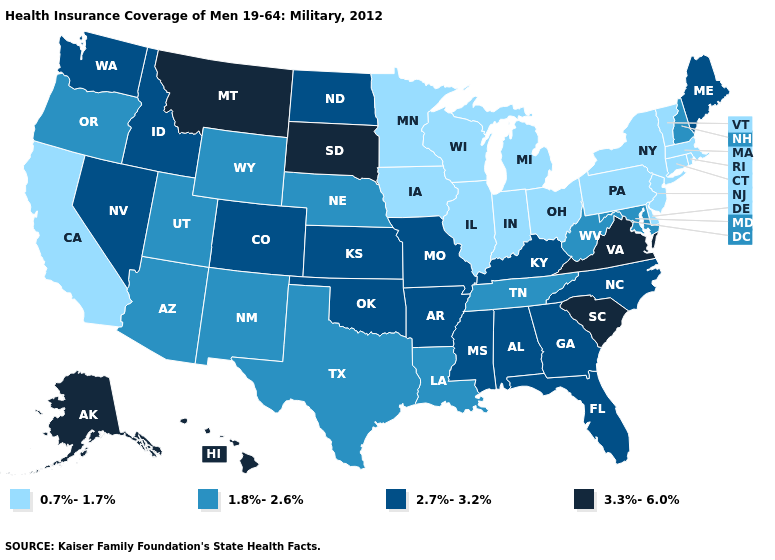What is the highest value in the USA?
Answer briefly. 3.3%-6.0%. What is the lowest value in the USA?
Concise answer only. 0.7%-1.7%. Which states have the lowest value in the USA?
Quick response, please. California, Connecticut, Delaware, Illinois, Indiana, Iowa, Massachusetts, Michigan, Minnesota, New Jersey, New York, Ohio, Pennsylvania, Rhode Island, Vermont, Wisconsin. Name the states that have a value in the range 1.8%-2.6%?
Quick response, please. Arizona, Louisiana, Maryland, Nebraska, New Hampshire, New Mexico, Oregon, Tennessee, Texas, Utah, West Virginia, Wyoming. What is the highest value in states that border Georgia?
Concise answer only. 3.3%-6.0%. What is the value of Utah?
Write a very short answer. 1.8%-2.6%. Among the states that border Vermont , which have the highest value?
Quick response, please. New Hampshire. What is the value of Colorado?
Keep it brief. 2.7%-3.2%. Name the states that have a value in the range 3.3%-6.0%?
Quick response, please. Alaska, Hawaii, Montana, South Carolina, South Dakota, Virginia. Does Maine have the same value as North Dakota?
Answer briefly. Yes. What is the value of New Mexico?
Keep it brief. 1.8%-2.6%. What is the lowest value in the Northeast?
Give a very brief answer. 0.7%-1.7%. What is the value of Mississippi?
Write a very short answer. 2.7%-3.2%. What is the value of South Dakota?
Give a very brief answer. 3.3%-6.0%. What is the value of Ohio?
Be succinct. 0.7%-1.7%. 